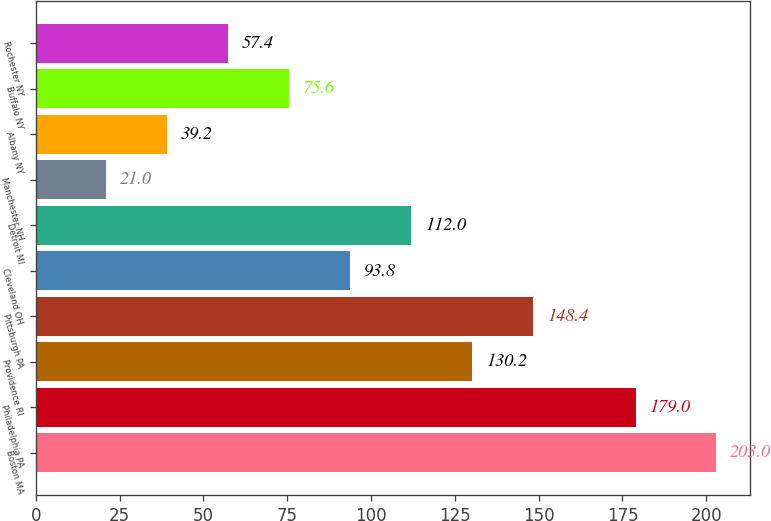Convert chart. <chart><loc_0><loc_0><loc_500><loc_500><bar_chart><fcel>Boston MA<fcel>Philadelphia PA<fcel>Providence RI<fcel>Pittsburgh PA<fcel>Cleveland OH<fcel>Detroit MI<fcel>Manchester NH<fcel>Albany NY<fcel>Buffalo NY<fcel>Rochester NY<nl><fcel>203<fcel>179<fcel>130.2<fcel>148.4<fcel>93.8<fcel>112<fcel>21<fcel>39.2<fcel>75.6<fcel>57.4<nl></chart> 